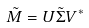Convert formula to latex. <formula><loc_0><loc_0><loc_500><loc_500>\tilde { M } = U \tilde { \Sigma } V ^ { * }</formula> 